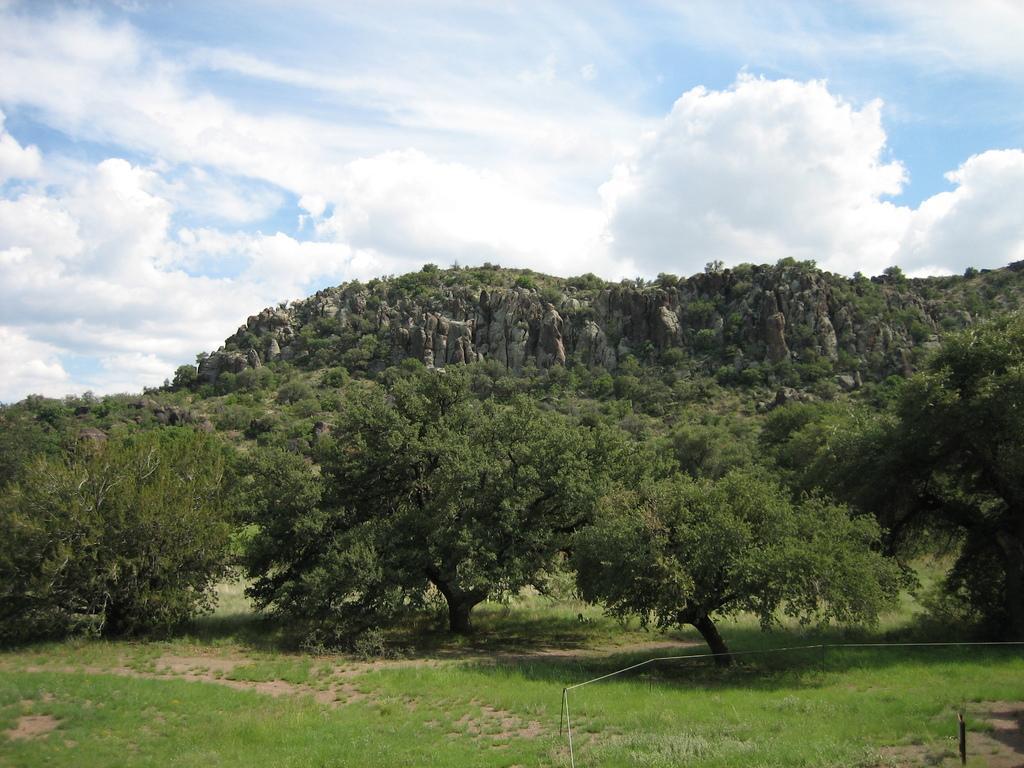How would you summarize this image in a sentence or two? This image is taken outdoors. At the bottom of the image there is a ground with grass on it. In the middle of the image there are a few hills and there are many plants and trees. At the top of the image there is a sky with clouds. 